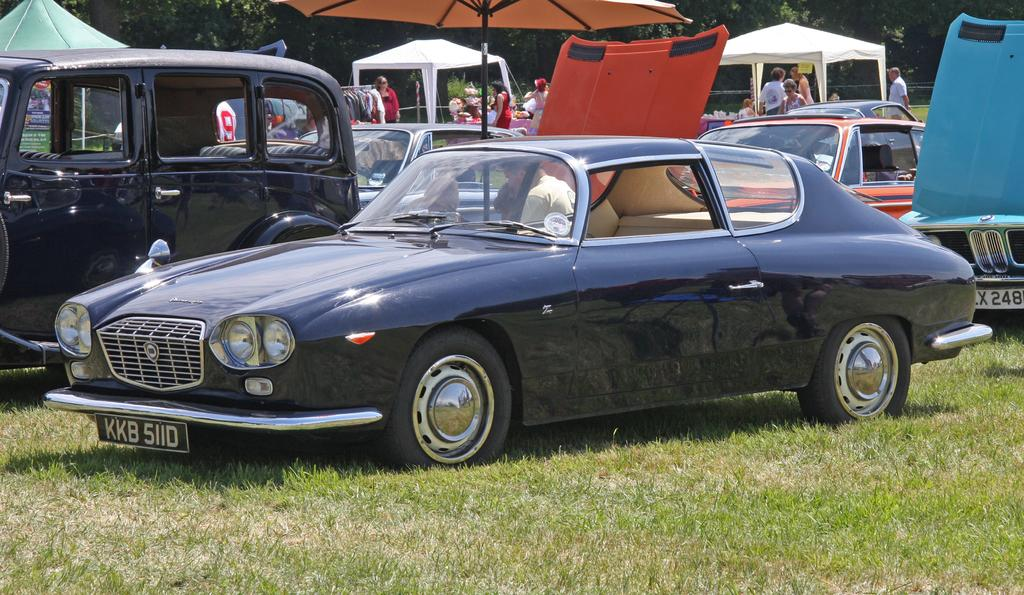What types of objects are present in the image? There are vehicles in the image. Can you describe the appearance of the vehicles? The vehicles are in different colors. What can be seen in the background of the image? There are tents, people, and trees in the background of the image. What type of government is being discussed in the image? There is no discussion or reference to any government in the image. 